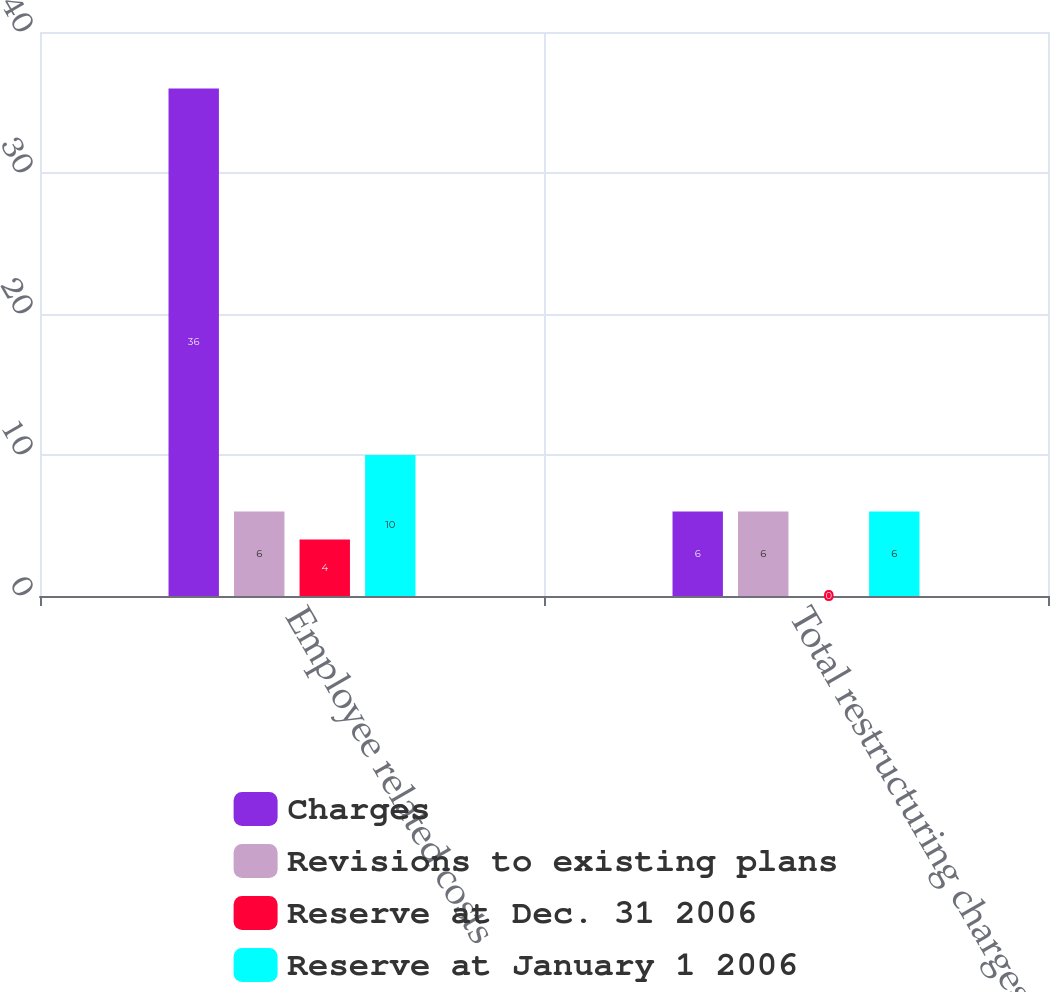Convert chart to OTSL. <chart><loc_0><loc_0><loc_500><loc_500><stacked_bar_chart><ecel><fcel>Employee related costs<fcel>Total restructuring charges<nl><fcel>Charges<fcel>36<fcel>6<nl><fcel>Revisions to existing plans<fcel>6<fcel>6<nl><fcel>Reserve at Dec. 31 2006<fcel>4<fcel>0<nl><fcel>Reserve at January 1 2006<fcel>10<fcel>6<nl></chart> 